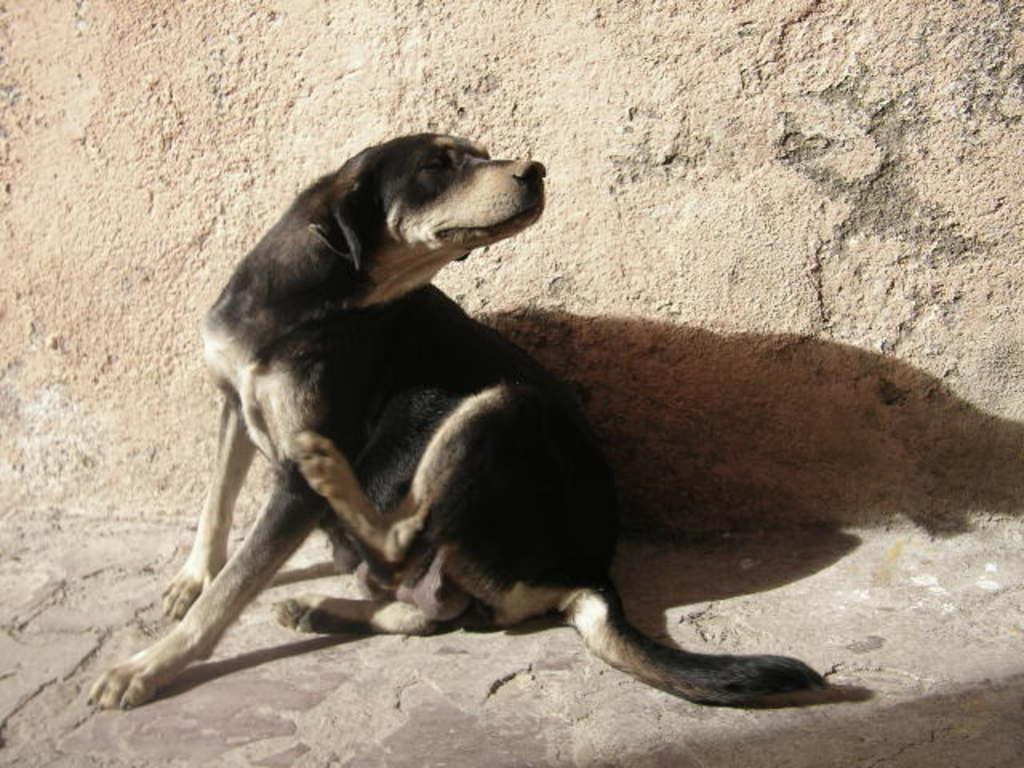What type of animal is in the image? There is a dog in the image. Can you describe the dog's coloring? The dog has black and brown coloring. What is the color of the background in the image? The background of the image is brown. How many turkeys can be seen in the image? There are no turkeys present in the image. 